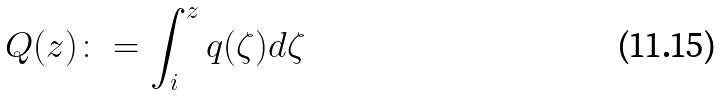Convert formula to latex. <formula><loc_0><loc_0><loc_500><loc_500>Q ( z ) \colon = \int _ { i } ^ { z } q ( \zeta ) d \zeta</formula> 